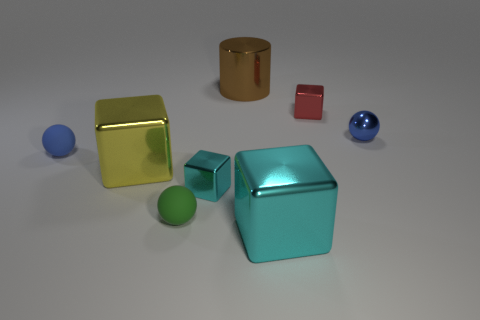Are there more small green things that are in front of the small red cube than tiny gray cubes?
Your answer should be very brief. Yes. There is a tiny blue thing that is made of the same material as the red block; what shape is it?
Give a very brief answer. Sphere. There is a blue object that is on the right side of the red cube; is it the same size as the big cyan shiny object?
Provide a short and direct response. No. There is a large shiny object that is in front of the big metallic thing that is to the left of the big brown cylinder; what shape is it?
Keep it short and to the point. Cube. There is a blue object to the left of the sphere that is in front of the small blue rubber object; what size is it?
Offer a terse response. Small. There is a matte object that is in front of the yellow metallic cube; what color is it?
Provide a succinct answer. Green. There is a cylinder that is the same material as the yellow block; what is its size?
Provide a succinct answer. Large. How many tiny red shiny things are the same shape as the tiny blue metal object?
Make the answer very short. 0. What material is the blue thing that is the same size as the blue metallic sphere?
Offer a terse response. Rubber. Is there a sphere that has the same material as the brown cylinder?
Ensure brevity in your answer.  Yes. 